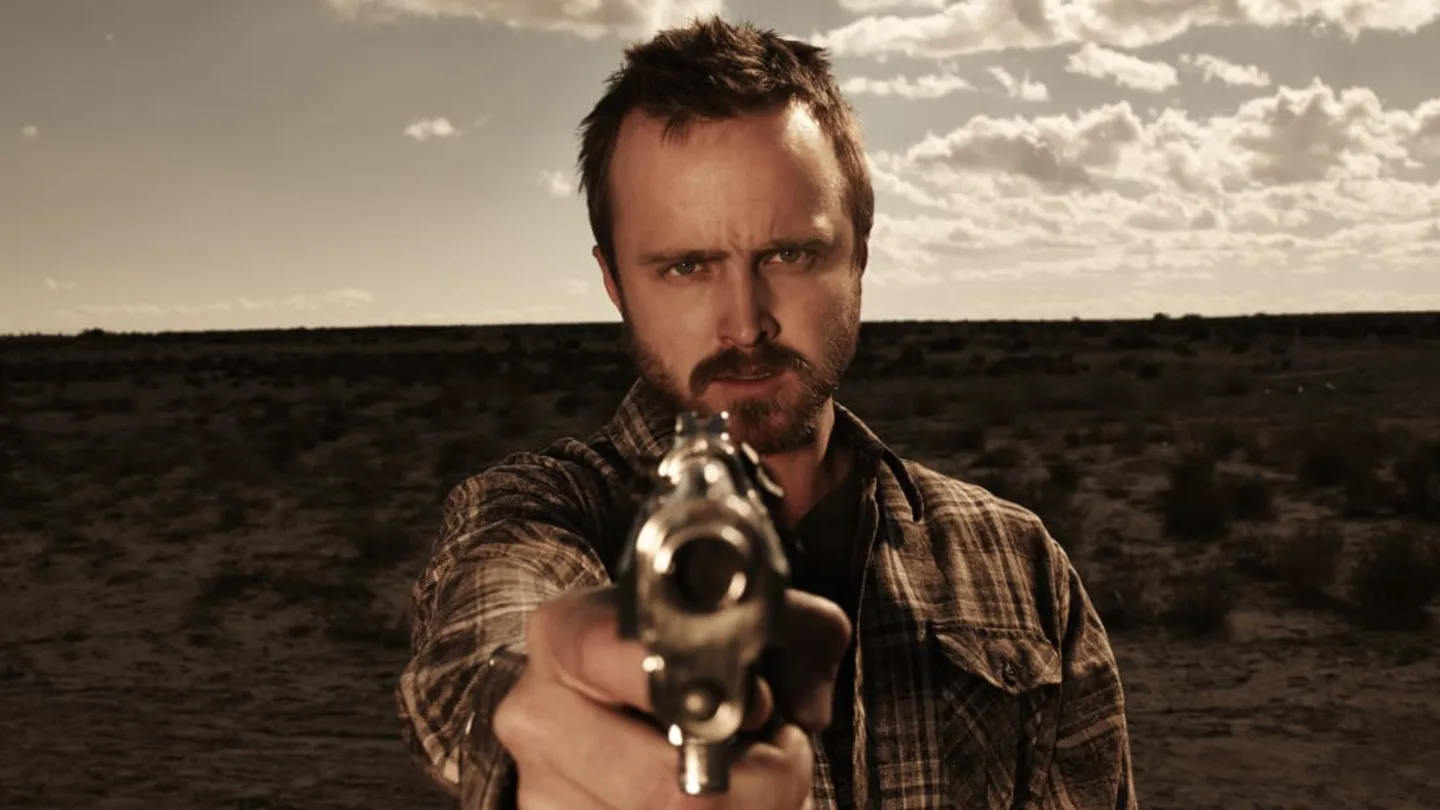Can you explore the mood created by the lighting and color tone in this image? The mood in the image is heightened by the use of warm sepia tones and a high-contrast lighting that casts dramatic shadows and highlights. This color scheme adds a vintage or timeless quality, suggesting a narrative rooted in intensity and perhaps danger. The shadows on the man's face and the glare from the sky create an ominous, foreboding atmosphere, enhancing the emotional impact of the image. 